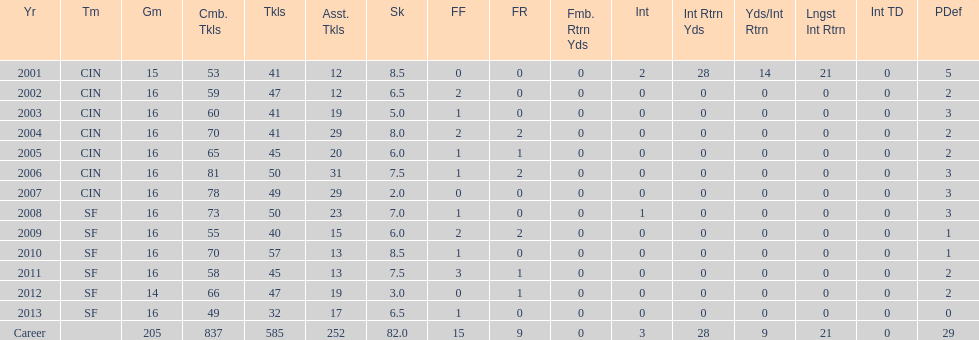How many consecutive years were there 20 or more assisted tackles? 5. 